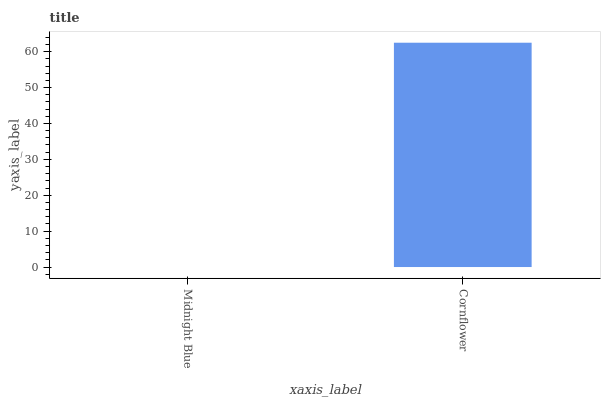Is Midnight Blue the minimum?
Answer yes or no. Yes. Is Cornflower the maximum?
Answer yes or no. Yes. Is Cornflower the minimum?
Answer yes or no. No. Is Cornflower greater than Midnight Blue?
Answer yes or no. Yes. Is Midnight Blue less than Cornflower?
Answer yes or no. Yes. Is Midnight Blue greater than Cornflower?
Answer yes or no. No. Is Cornflower less than Midnight Blue?
Answer yes or no. No. Is Cornflower the high median?
Answer yes or no. Yes. Is Midnight Blue the low median?
Answer yes or no. Yes. Is Midnight Blue the high median?
Answer yes or no. No. Is Cornflower the low median?
Answer yes or no. No. 